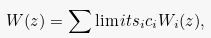Convert formula to latex. <formula><loc_0><loc_0><loc_500><loc_500>W ( z ) = \sum \lim i t s _ { i } c _ { i } W _ { i } ( z ) ,</formula> 